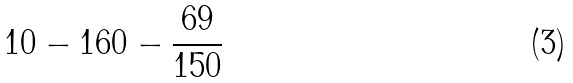Convert formula to latex. <formula><loc_0><loc_0><loc_500><loc_500>1 0 - 1 6 0 - \frac { 6 9 } { 1 5 0 }</formula> 